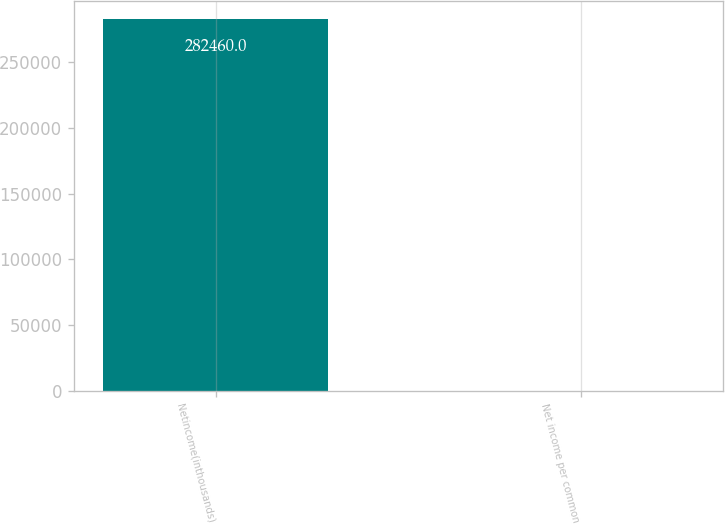<chart> <loc_0><loc_0><loc_500><loc_500><bar_chart><fcel>Netincome(inthousands)<fcel>Net income per common<nl><fcel>282460<fcel>2.6<nl></chart> 